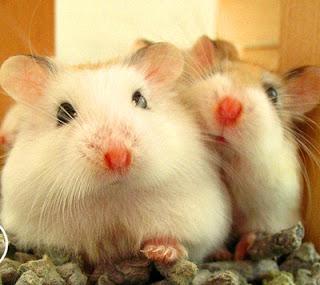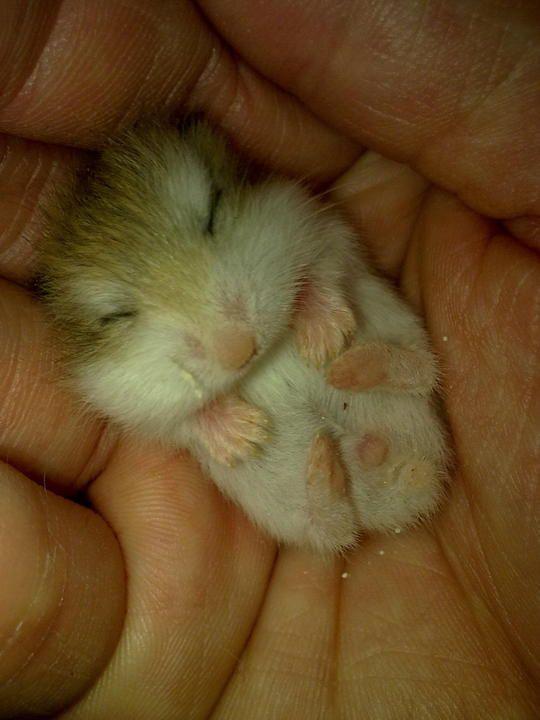The first image is the image on the left, the second image is the image on the right. For the images displayed, is the sentence "One image shows side-by-side hamsters, and the other shows one small pet in an upturned palm." factually correct? Answer yes or no. Yes. The first image is the image on the left, the second image is the image on the right. Analyze the images presented: Is the assertion "The right image contains at least two hamsters." valid? Answer yes or no. No. 